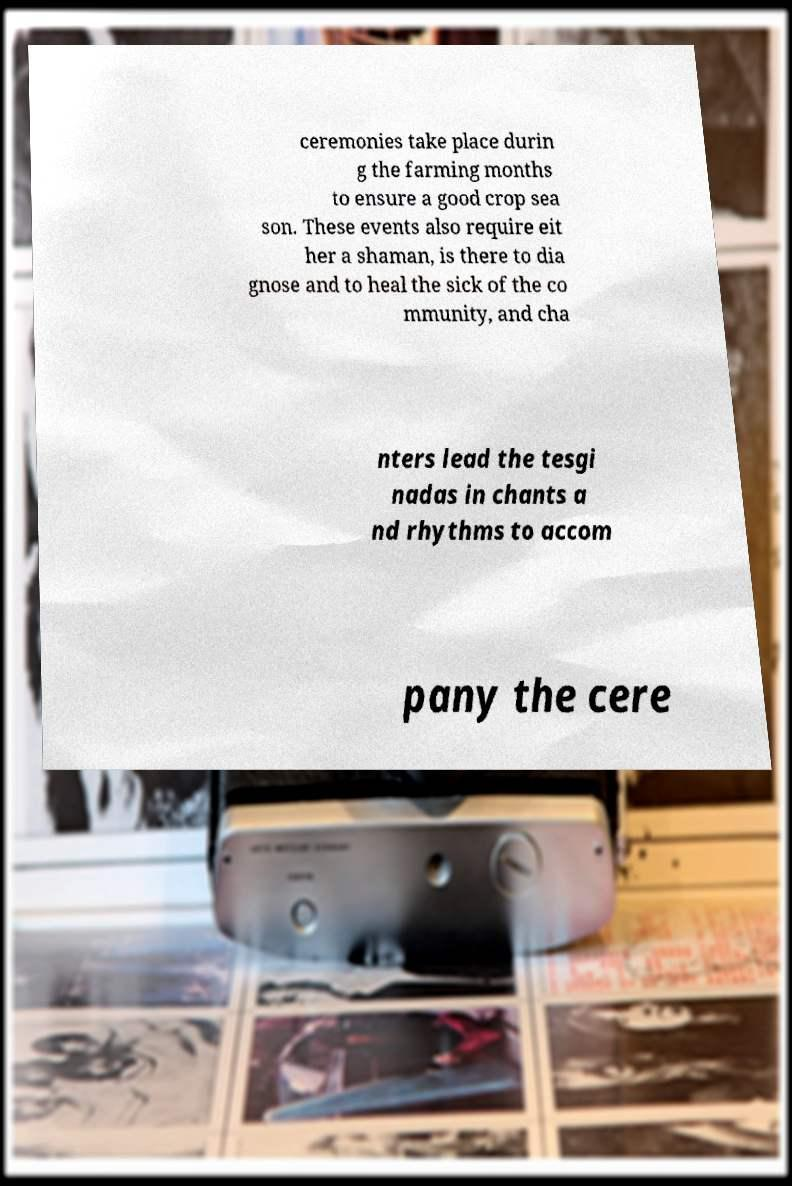Please read and relay the text visible in this image. What does it say? ceremonies take place durin g the farming months to ensure a good crop sea son. These events also require eit her a shaman, is there to dia gnose and to heal the sick of the co mmunity, and cha nters lead the tesgi nadas in chants a nd rhythms to accom pany the cere 